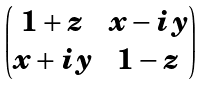<formula> <loc_0><loc_0><loc_500><loc_500>\begin{pmatrix} 1 + z & x - i y \\ x + i y & 1 - z \end{pmatrix}</formula> 